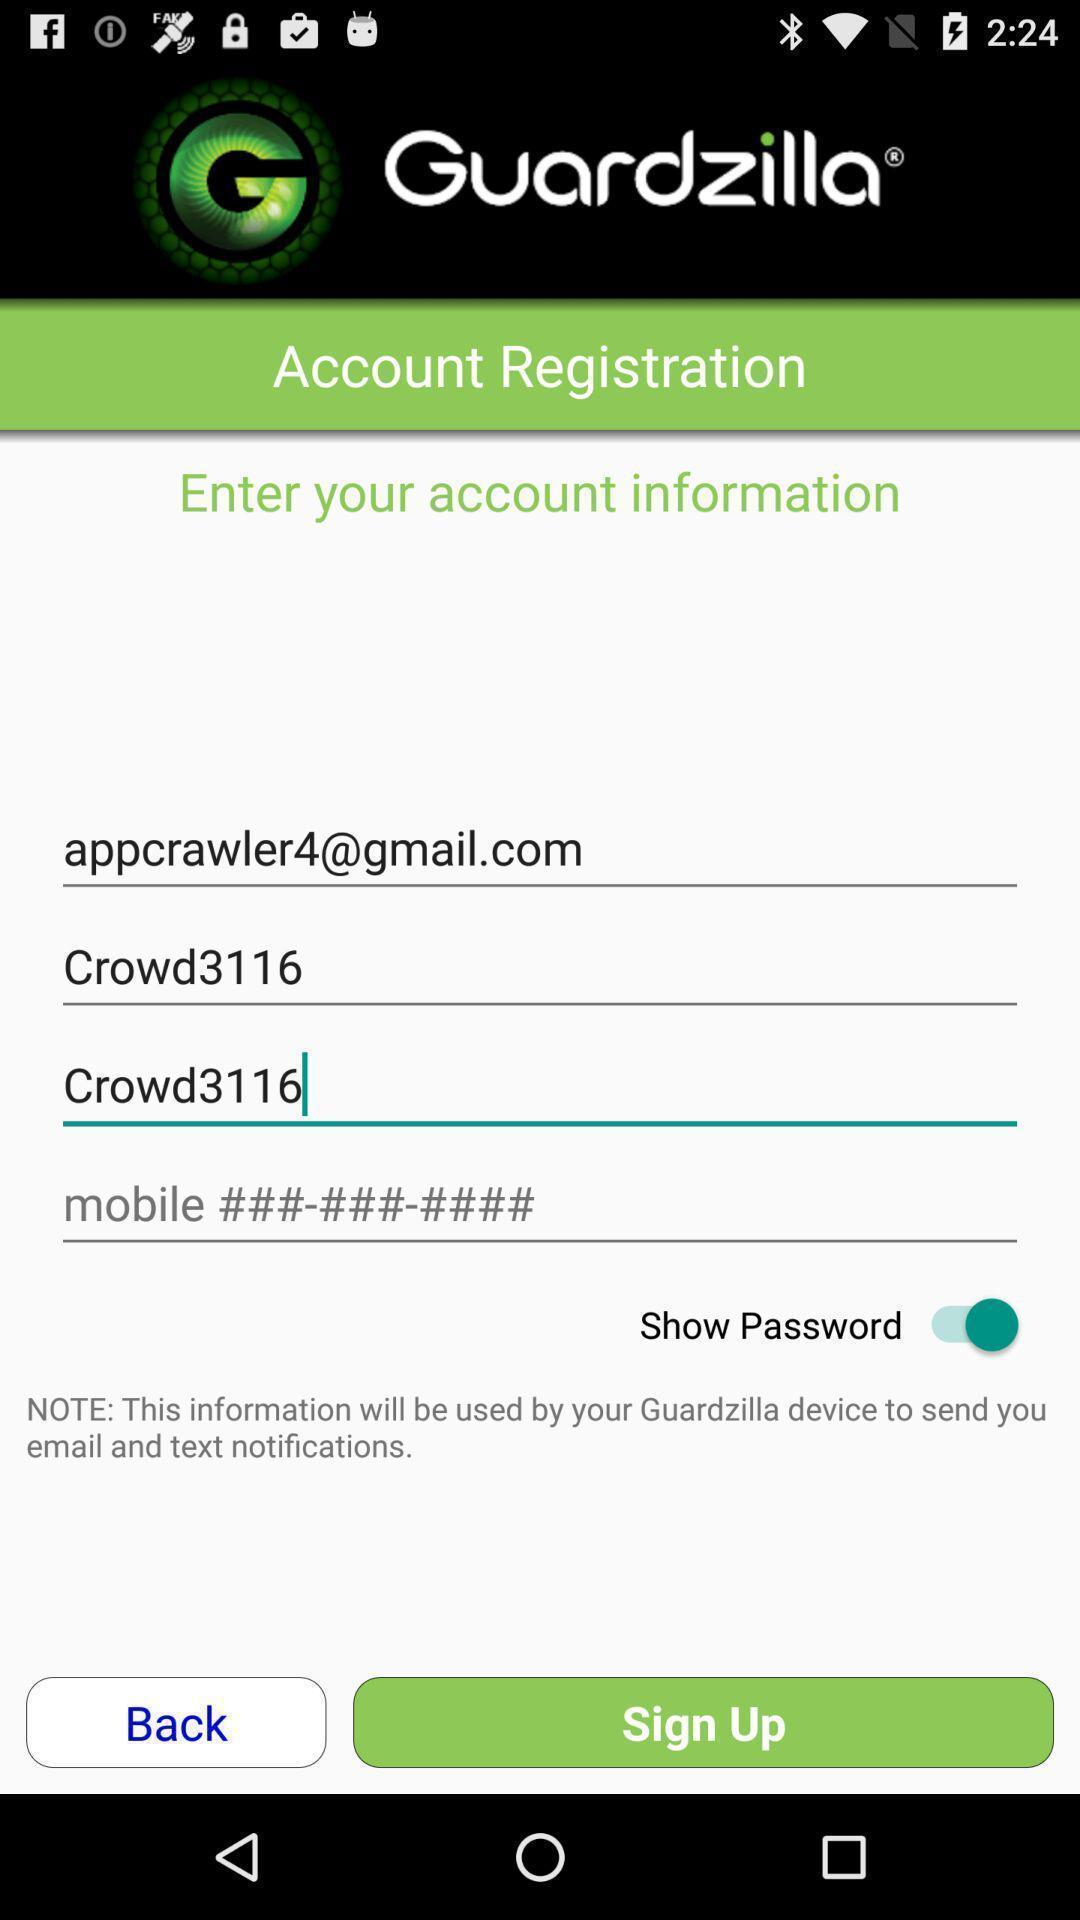Describe the content in this image. Sign up page. 